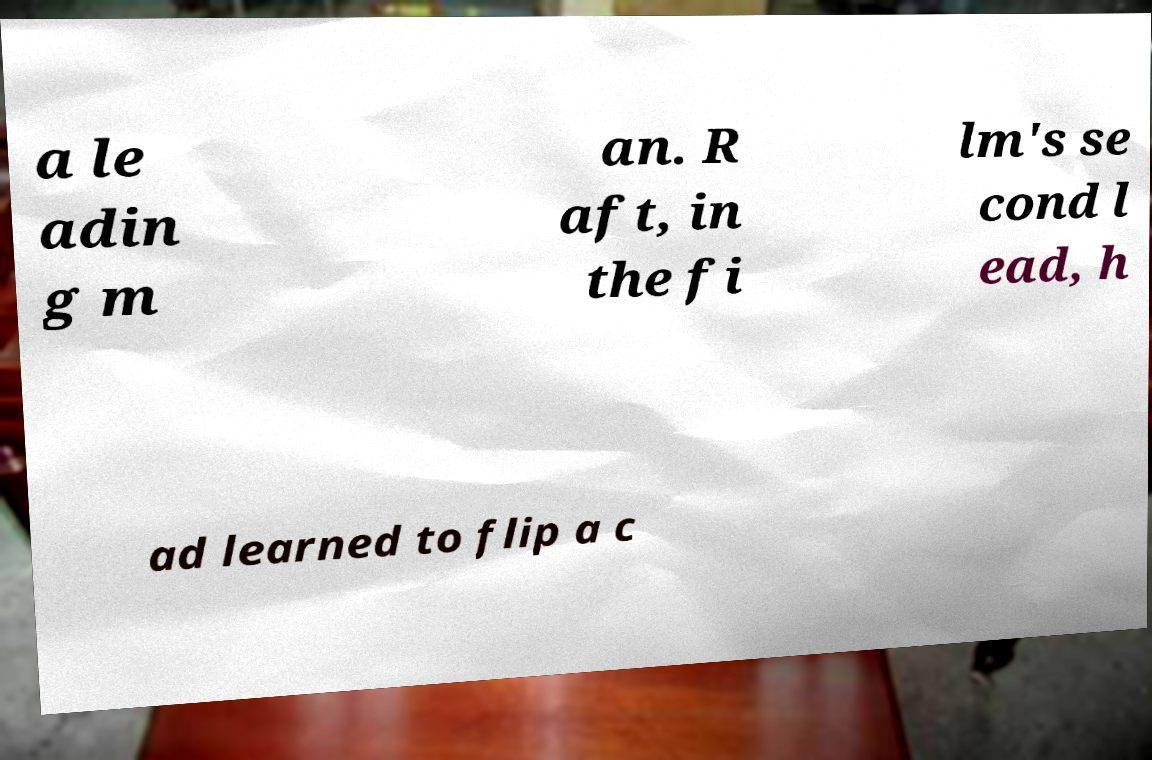Please read and relay the text visible in this image. What does it say? a le adin g m an. R aft, in the fi lm's se cond l ead, h ad learned to flip a c 